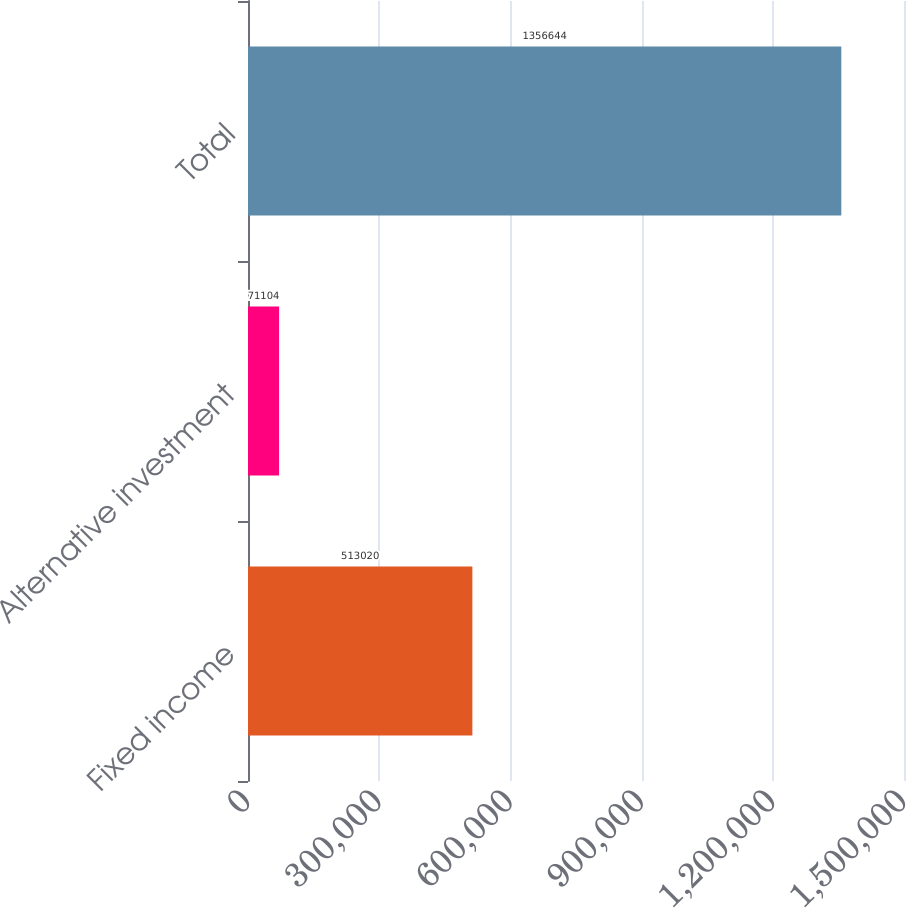Convert chart. <chart><loc_0><loc_0><loc_500><loc_500><bar_chart><fcel>Fixed income<fcel>Alternative investment<fcel>Total<nl><fcel>513020<fcel>71104<fcel>1.35664e+06<nl></chart> 